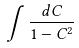<formula> <loc_0><loc_0><loc_500><loc_500>\int \frac { d C } { 1 - C ^ { 2 } }</formula> 